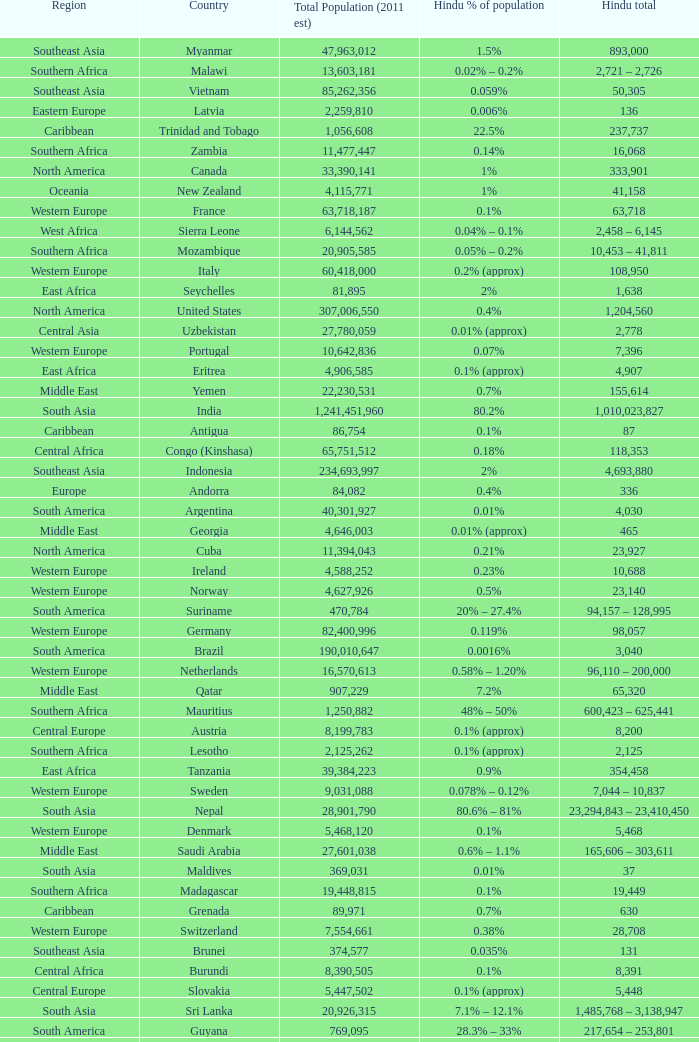Total Population (2011 est) larger than 30,262,610, and a Hindu total of 63,718 involves what country? France. 